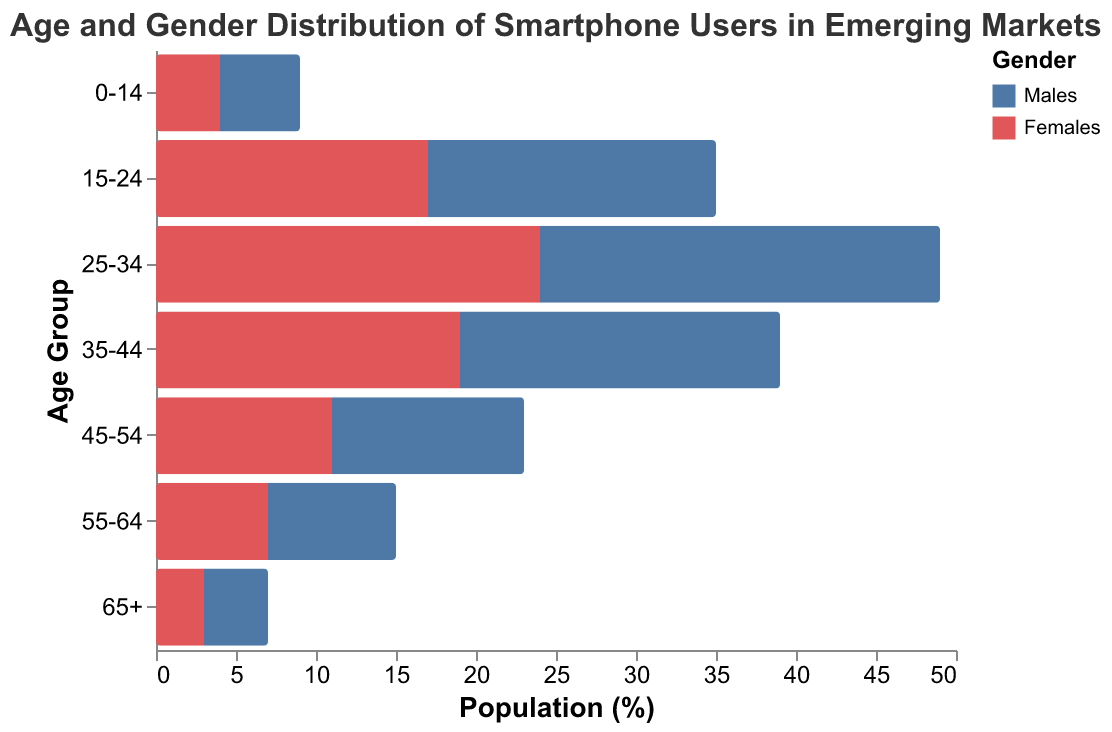What is the title of the figure? The title of the figure can typically be found at the top of the chart. In this case, it is "Age and Gender Distribution of Smartphone Users in Emerging Markets".
Answer: Age and Gender Distribution of Smartphone Users in Emerging Markets How many age groups are represented in the figure? Count the number of different age groups listed on the y-axis. The age groups are "0-14", "15-24", "25-34", "35-44", "45-54", "55-64", and "65+". There are 7 age groups in total.
Answer: 7 Which age group has the highest number of male smartphone users? Look at the length of the bars on the left side of the pyramid, which represents males. The age group "25-34" has the longest bar to the left, indicating the highest number of male smartphone users.
Answer: 25-34 Compare the female smartphone users in the "15-24" and "65+" age groups. Which group has more users and by how much? The length of the bars on the right side of the pyramid represents females. The "15-24" age group has a bar length of 17, while the "65+" age group has a bar length of 3. The "15-24" age group has 14 more female users than the "65+" age group.
Answer: 15-24; 14 What is the difference between the number of male and female smartphone users in the "35-44" age group? The length of the bars for males and females in the "35-44" age group needs to be compared. Males: -20, Females: 19. The difference is the absolute value of (-20 - 19) = 39.
Answer: 39 Are there more female users than male users in any age group? If so, which ones? Compare the lengths of the bars for males and females. Female bars are on the positive side, and male bars are on the negative side. If the female bar is longer than the male bar (ignoring the sign), there are more female users in that group. This is the case for "0-14" (4 > -5).
Answer: 0-14 Which gender has a higher representation in the 55-64 age group? Compare the lengths of the bars for both genders in the "55-64" age group. Males have -8 and females have 7. Since -8 is less in magnitude than 7, more females are represented.
Answer: Females 